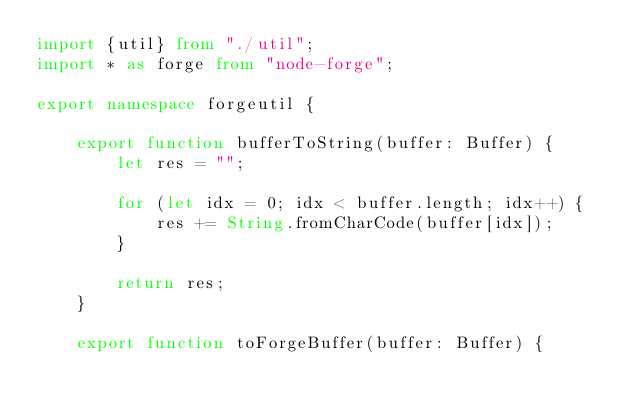<code> <loc_0><loc_0><loc_500><loc_500><_TypeScript_>import {util} from "./util";
import * as forge from "node-forge";

export namespace forgeutil {

    export function bufferToString(buffer: Buffer) {
        let res = "";

        for (let idx = 0; idx < buffer.length; idx++) {
            res += String.fromCharCode(buffer[idx]);
        }

        return res;
    }

    export function toForgeBuffer(buffer: Buffer) {</code> 